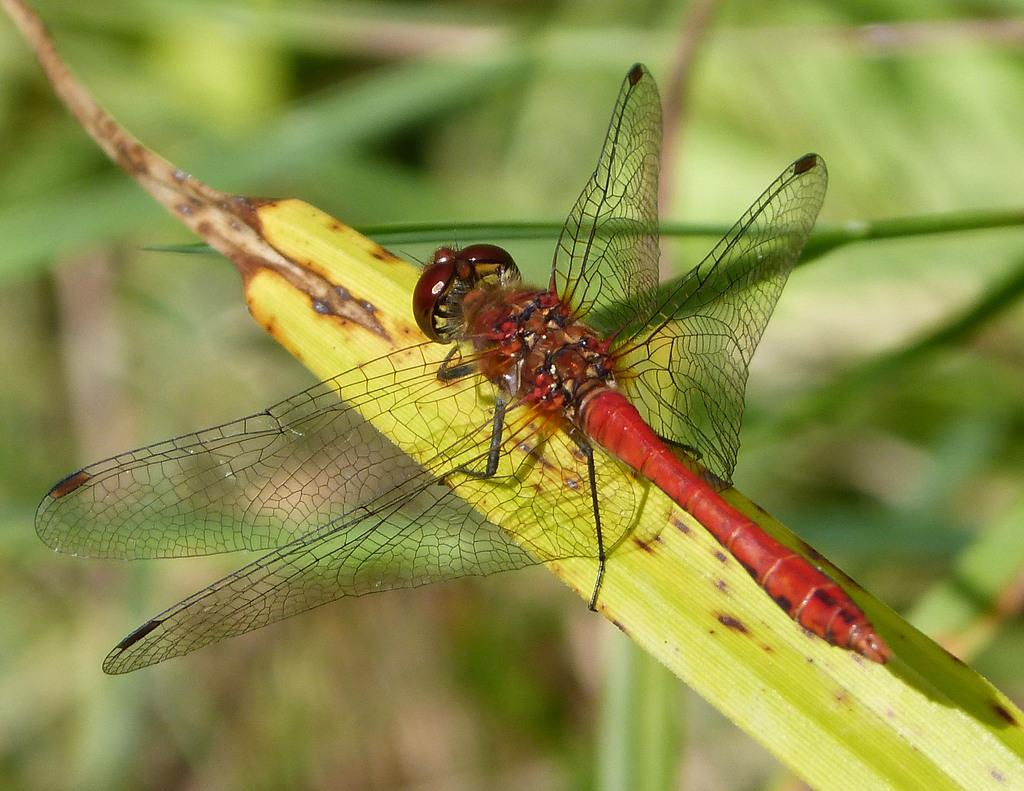What is the main subject of the image? There is a dragonfly in the center of the image. Where is the dragonfly located? The dragonfly is on a leaf. What can be seen in the background of the image? There is greenery in the background of the image. How does the dragonfly force the other insects to play in the image? There is no indication in the image that the dragonfly is forcing other insects to play or that there are any other insects present. 